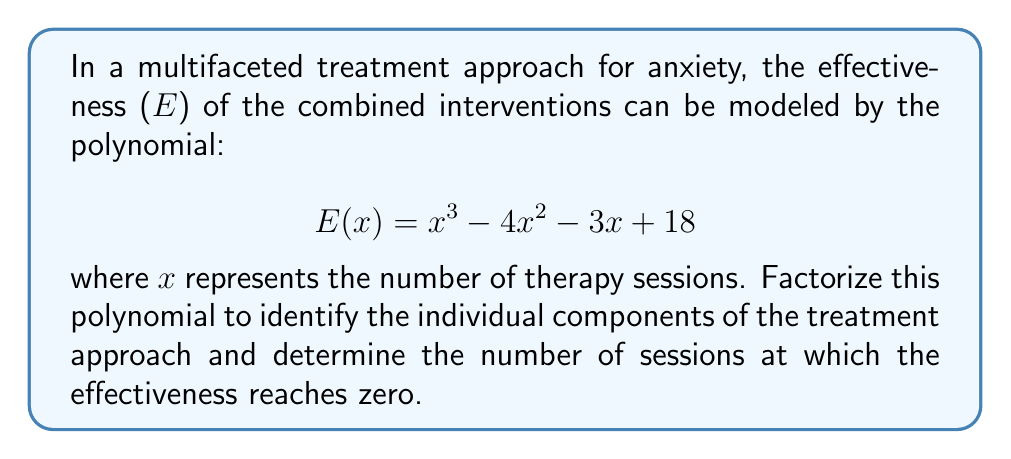Can you answer this question? To factorize the polynomial $E(x) = x^3 - 4x^2 - 3x + 18$, we'll follow these steps:

1) First, let's check if there's a common factor. There isn't, so we proceed to the next step.

2) We'll use the rational root theorem to find potential roots. The factors of the constant term (18) are ±1, ±2, ±3, ±6, ±9, ±18.

3) Testing these values, we find that x = 3 is a root. So (x - 3) is a factor.

4) Divide the polynomial by (x - 3):

   $x^3 - 4x^2 - 3x + 18 = (x - 3)(x^2 - x - 6)$

5) Now we need to factor $x^2 - x - 6$. This is a quadratic equation.

6) For $ax^2 + bx + c$, we have $a=1$, $b=-1$, and $c=-6$.

7) We're looking for two numbers that multiply to give $ac = -6$ and add to give $b = -1$.

8) These numbers are 2 and -3.

9) So, $x^2 - x - 6 = (x + 2)(x - 3)$

Therefore, the fully factored polynomial is:

$$E(x) = (x - 3)(x + 2)(x - 3)$$

The roots of this polynomial (where E(x) = 0) are x = 3 (twice) and x = -2.

In the context of the treatment approach, this factorization reveals three components:
- (x - 3) appears twice, suggesting a critical threshold at 3 sessions
- (x + 2) indicates another factor influencing effectiveness

The effectiveness reaches zero at x = 3 (positive, realistic solution) or x = -2 (which isn't meaningful in this context as the number of sessions can't be negative).
Answer: $E(x) = (x - 3)^2(x + 2)$; Effectiveness reaches zero at 3 sessions. 